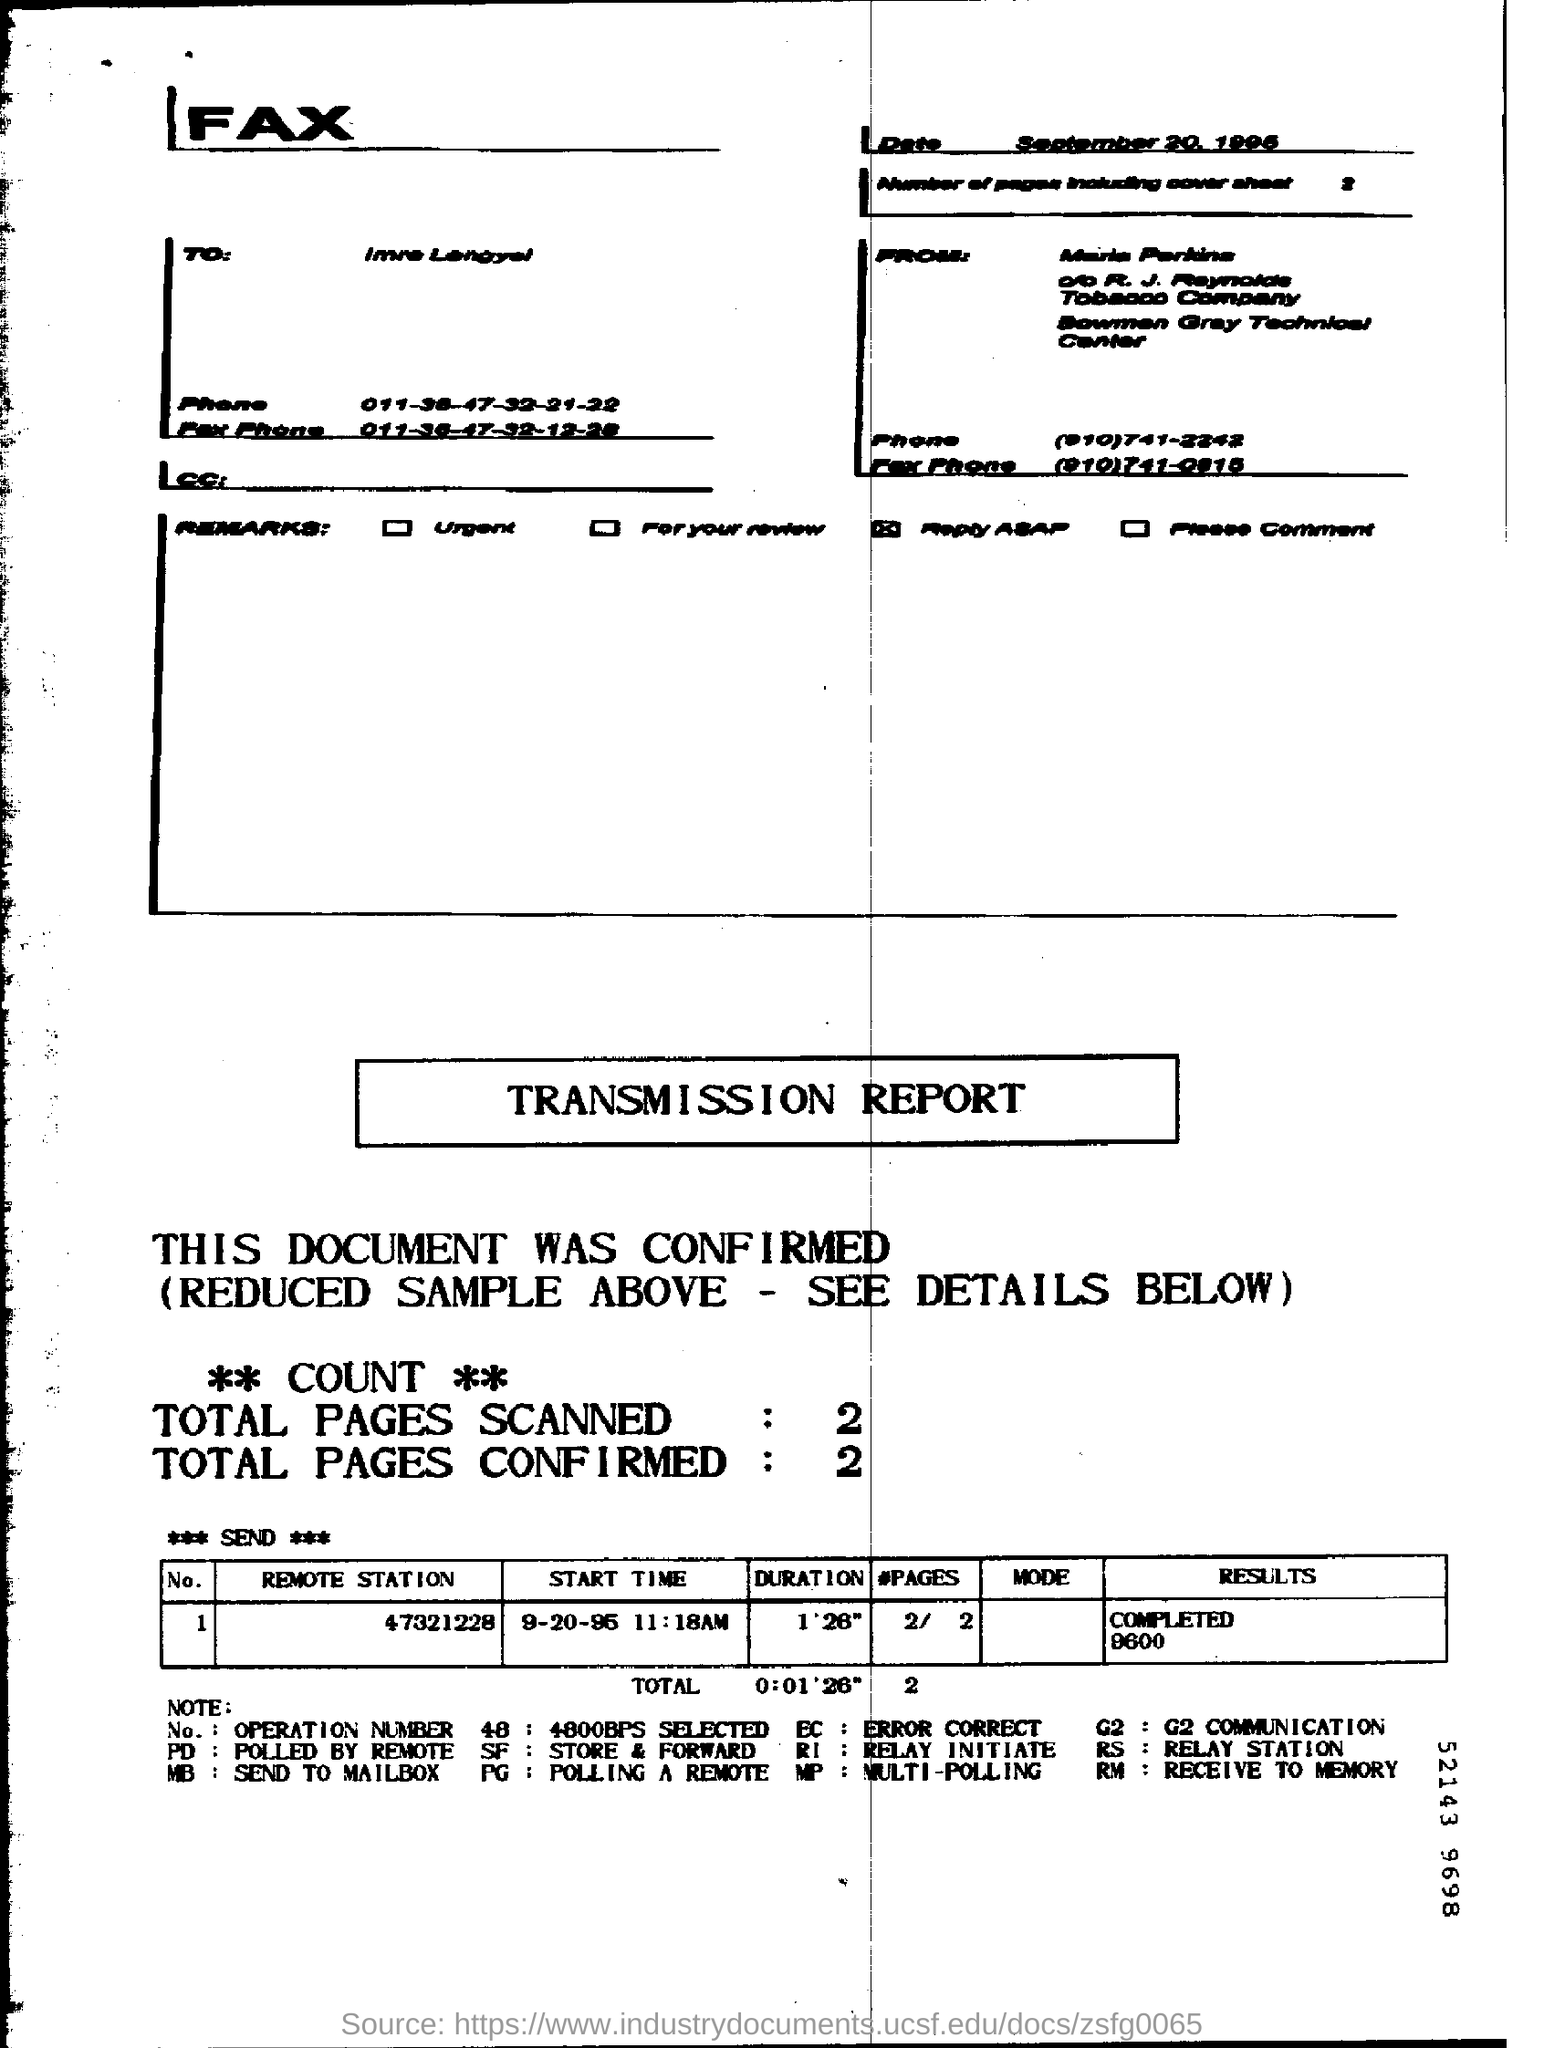Identify some key points in this picture. What is the duration for the remote station 47321228? It is 1 minute and 26 seconds. The result for the "Remote station" with the identifier 47321228 has been completed with a value of 9600. What are the total number of pages confirmed? There are currently two pages. The date is September 20, 1995. The total number of pages scanned is two. 